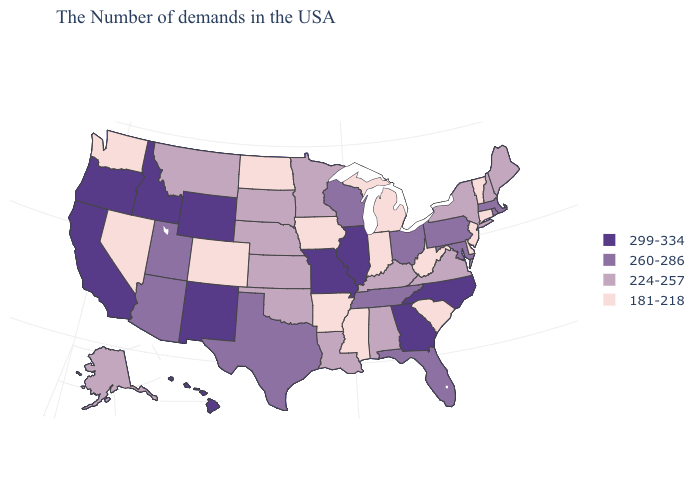Does Missouri have the highest value in the USA?
Keep it brief. Yes. What is the value of Iowa?
Answer briefly. 181-218. Does Nevada have the lowest value in the USA?
Quick response, please. Yes. Does the map have missing data?
Keep it brief. No. Among the states that border Maryland , does West Virginia have the lowest value?
Keep it brief. Yes. Does California have a higher value than Idaho?
Short answer required. No. Among the states that border Indiana , which have the highest value?
Give a very brief answer. Illinois. Name the states that have a value in the range 181-218?
Short answer required. Vermont, Connecticut, New Jersey, Delaware, South Carolina, West Virginia, Michigan, Indiana, Mississippi, Arkansas, Iowa, North Dakota, Colorado, Nevada, Washington. Is the legend a continuous bar?
Write a very short answer. No. Does Ohio have the highest value in the USA?
Give a very brief answer. No. Name the states that have a value in the range 299-334?
Quick response, please. North Carolina, Georgia, Illinois, Missouri, Wyoming, New Mexico, Idaho, California, Oregon, Hawaii. What is the value of South Carolina?
Answer briefly. 181-218. What is the value of Alaska?
Keep it brief. 224-257. What is the lowest value in the USA?
Answer briefly. 181-218. 